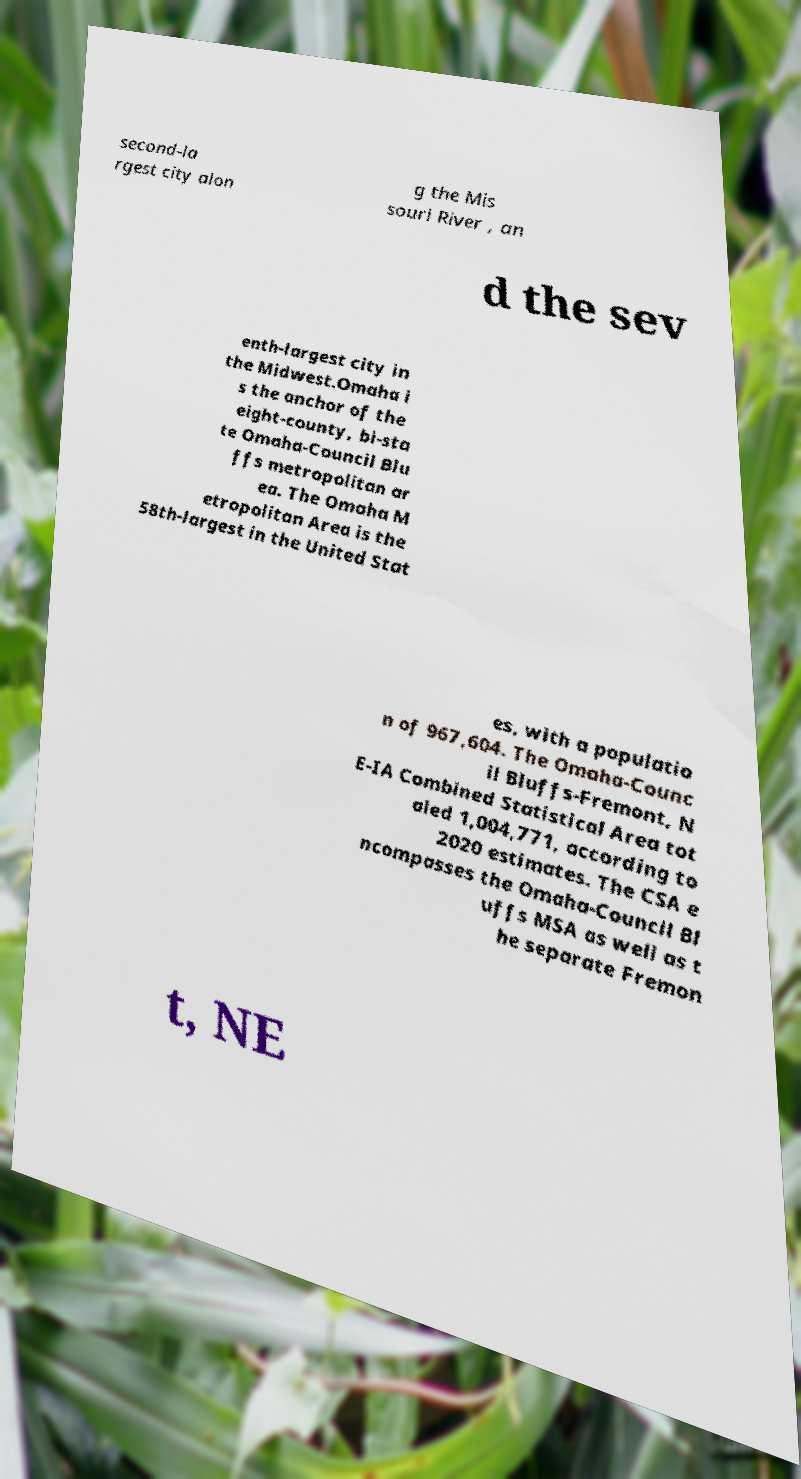For documentation purposes, I need the text within this image transcribed. Could you provide that? second-la rgest city alon g the Mis souri River , an d the sev enth-largest city in the Midwest.Omaha i s the anchor of the eight-county, bi-sta te Omaha-Council Blu ffs metropolitan ar ea. The Omaha M etropolitan Area is the 58th-largest in the United Stat es, with a populatio n of 967,604. The Omaha-Counc il Bluffs-Fremont, N E-IA Combined Statistical Area tot aled 1,004,771, according to 2020 estimates. The CSA e ncompasses the Omaha-Council Bl uffs MSA as well as t he separate Fremon t, NE 